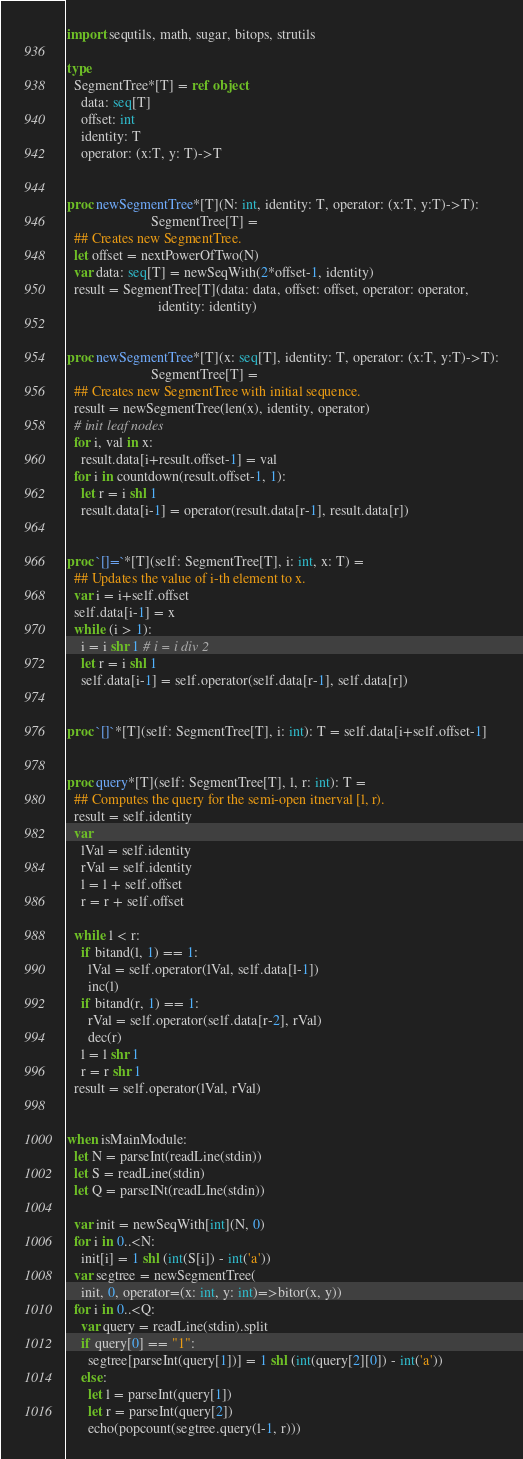<code> <loc_0><loc_0><loc_500><loc_500><_Nim_>import sequtils, math, sugar, bitops, strutils

type
  SegmentTree*[T] = ref object
    data: seq[T]
    offset: int
    identity: T
    operator: (x:T, y: T)->T


proc newSegmentTree*[T](N: int, identity: T, operator: (x:T, y:T)->T):
                        SegmentTree[T] =
  ## Creates new SegmentTree.
  let offset = nextPowerOfTwo(N)
  var data: seq[T] = newSeqWith(2*offset-1, identity)
  result = SegmentTree[T](data: data, offset: offset, operator: operator,
                          identity: identity)


proc newSegmentTree*[T](x: seq[T], identity: T, operator: (x:T, y:T)->T):
                        SegmentTree[T] =
  ## Creates new SegmentTree with initial sequence.
  result = newSegmentTree(len(x), identity, operator)
  # init leaf nodes
  for i, val in x:
    result.data[i+result.offset-1] = val
  for i in countdown(result.offset-1, 1):
    let r = i shl 1
    result.data[i-1] = operator(result.data[r-1], result.data[r])


proc `[]=`*[T](self: SegmentTree[T], i: int, x: T) =
  ## Updates the value of i-th element to x.
  var i = i+self.offset
  self.data[i-1] = x
  while (i > 1):
    i = i shr 1 # i = i div 2
    let r = i shl 1
    self.data[i-1] = self.operator(self.data[r-1], self.data[r])


proc `[]`*[T](self: SegmentTree[T], i: int): T = self.data[i+self.offset-1]


proc query*[T](self: SegmentTree[T], l, r: int): T =
  ## Computes the query for the semi-open itnerval [l, r).
  result = self.identity
  var
    lVal = self.identity
    rVal = self.identity
    l = l + self.offset
    r = r + self.offset

  while l < r:
    if bitand(l, 1) == 1: 
      lVal = self.operator(lVal, self.data[l-1])
      inc(l)
    if bitand(r, 1) == 1:
      rVal = self.operator(self.data[r-2], rVal)
      dec(r)
    l = l shr 1
    r = r shr 1
  result = self.operator(lVal, rVal)


when isMainModule:
  let N = parseInt(readLine(stdin))
  let S = readLine(stdin)
  let Q = parseINt(readLIne(stdin))

  var init = newSeqWith[int](N, 0)
  for i in 0..<N:
    init[i] = 1 shl (int(S[i]) - int('a'))
  var segtree = newSegmentTree(
    init, 0, operator=(x: int, y: int)=>bitor(x, y))
  for i in 0..<Q:
    var query = readLine(stdin).split
    if query[0] == "1":
      segtree[parseInt(query[1])] = 1 shl (int(query[2][0]) - int('a'))
    else:
      let l = parseInt(query[1])
      let r = parseInt(query[2])
      echo(popcount(segtree.query(l-1, r)))
</code> 